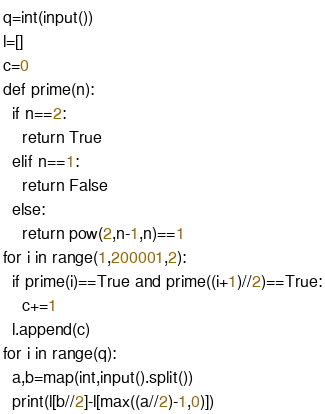<code> <loc_0><loc_0><loc_500><loc_500><_Python_>q=int(input())
l=[]
c=0
def prime(n):
  if n==2:
    return True
  elif n==1:
    return False
  else:
    return pow(2,n-1,n)==1
for i in range(1,200001,2):
  if prime(i)==True and prime((i+1)//2)==True:
    c+=1
  l.append(c)
for i in range(q):
  a,b=map(int,input().split())
  print(l[b//2]-l[max((a//2)-1,0)])
</code> 